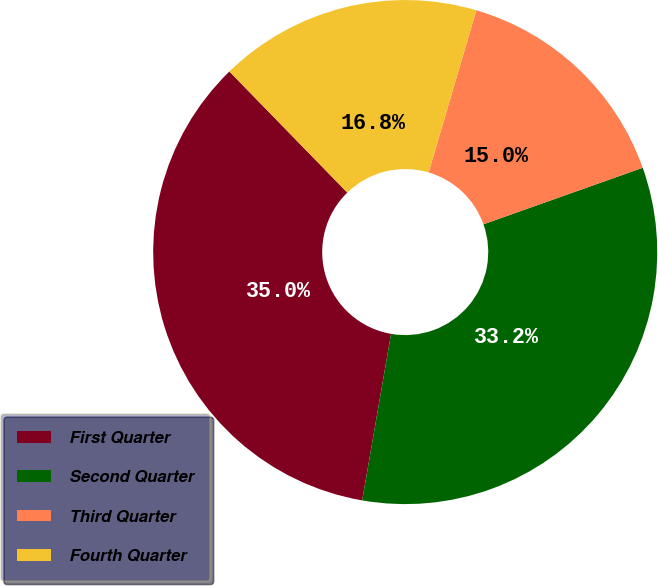<chart> <loc_0><loc_0><loc_500><loc_500><pie_chart><fcel>First Quarter<fcel>Second Quarter<fcel>Third Quarter<fcel>Fourth Quarter<nl><fcel>34.98%<fcel>33.16%<fcel>15.02%<fcel>16.84%<nl></chart> 